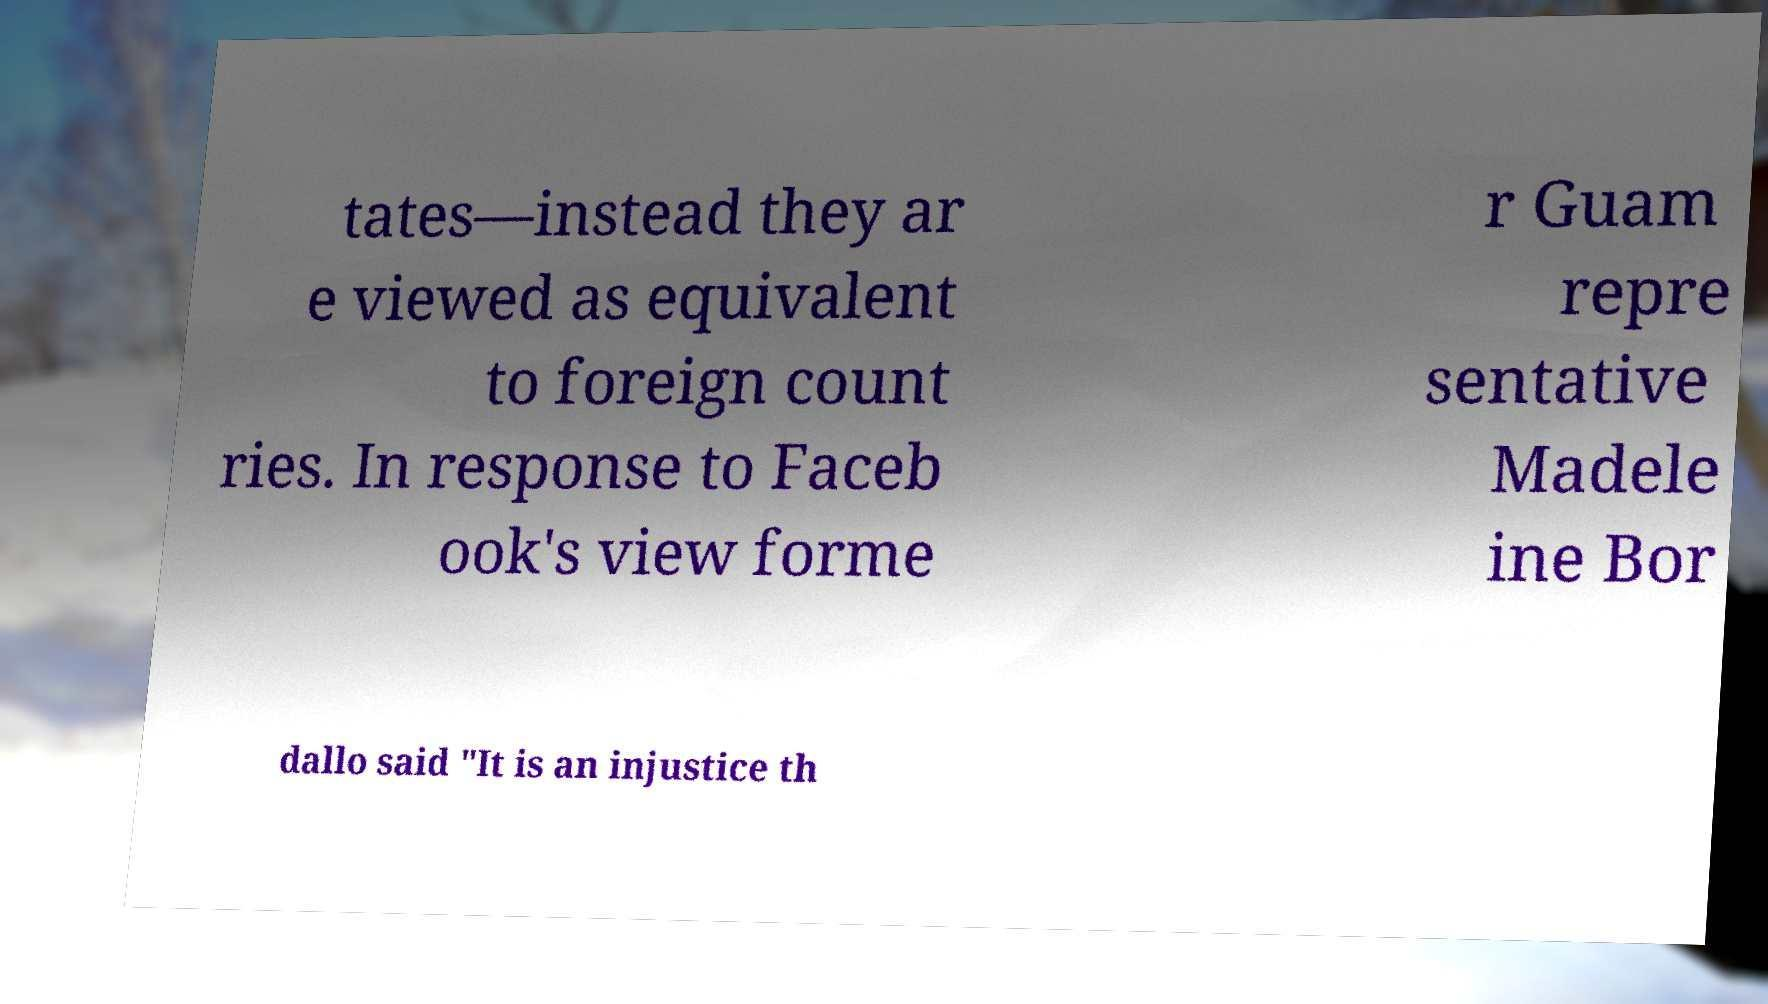Could you extract and type out the text from this image? tates—instead they ar e viewed as equivalent to foreign count ries. In response to Faceb ook's view forme r Guam repre sentative Madele ine Bor dallo said "It is an injustice th 